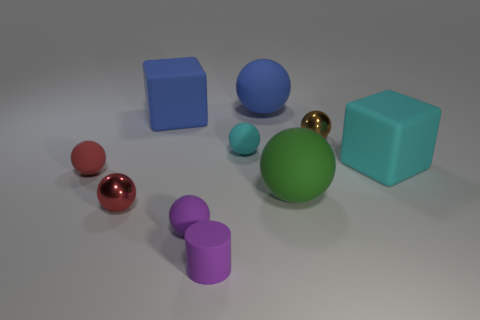The rubber ball that is the same color as the cylinder is what size?
Keep it short and to the point. Small. What number of blocks are either big cyan matte things or purple things?
Provide a succinct answer. 1. The red rubber object is what size?
Provide a short and direct response. Small. How many red matte balls are on the left side of the green matte ball?
Your answer should be compact. 1. What is the size of the blue object that is on the left side of the blue thing that is to the right of the small purple matte cylinder?
Offer a very short reply. Large. There is a tiny red object that is on the left side of the red shiny object; is it the same shape as the red object that is on the right side of the small red rubber sphere?
Keep it short and to the point. Yes. What shape is the big object that is in front of the large matte block in front of the large blue matte block?
Your response must be concise. Sphere. There is a ball that is to the right of the tiny red rubber ball and left of the small purple matte sphere; what is its size?
Offer a very short reply. Small. There is a big green matte thing; is it the same shape as the big blue rubber object that is on the left side of the blue ball?
Offer a very short reply. No. There is a brown thing that is the same shape as the green object; what is its size?
Make the answer very short. Small. 